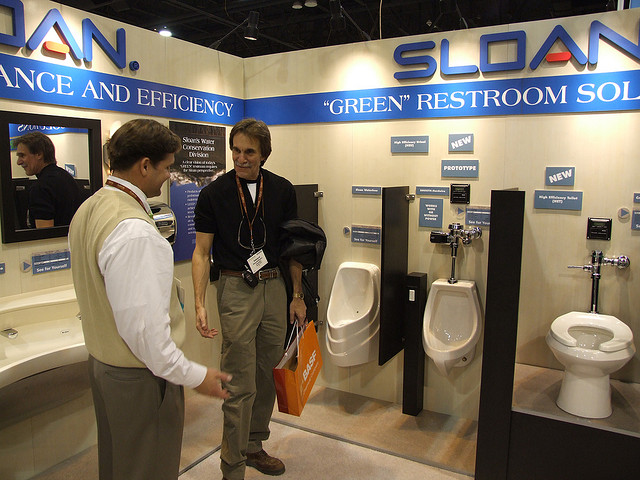Please transcribe the text information in this image. SLOAN "GREEN" RESTROMM EFFICIENCY SOL PEDIOTYPE NEW NEW AND ANCE SLOAN 